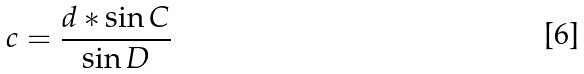Convert formula to latex. <formula><loc_0><loc_0><loc_500><loc_500>c = \frac { d * \sin C } { \sin D }</formula> 